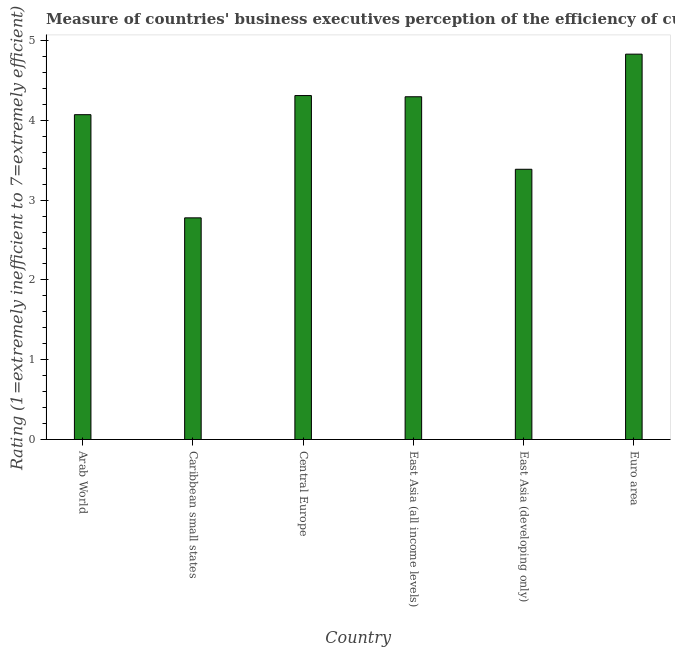Does the graph contain grids?
Offer a very short reply. No. What is the title of the graph?
Give a very brief answer. Measure of countries' business executives perception of the efficiency of customs procedures in 2007. What is the label or title of the X-axis?
Ensure brevity in your answer.  Country. What is the label or title of the Y-axis?
Offer a terse response. Rating (1=extremely inefficient to 7=extremely efficient). What is the rating measuring burden of customs procedure in Caribbean small states?
Ensure brevity in your answer.  2.78. Across all countries, what is the maximum rating measuring burden of customs procedure?
Offer a very short reply. 4.83. Across all countries, what is the minimum rating measuring burden of customs procedure?
Ensure brevity in your answer.  2.78. In which country was the rating measuring burden of customs procedure minimum?
Make the answer very short. Caribbean small states. What is the sum of the rating measuring burden of customs procedure?
Your answer should be very brief. 23.67. What is the difference between the rating measuring burden of customs procedure in Arab World and Caribbean small states?
Keep it short and to the point. 1.29. What is the average rating measuring burden of customs procedure per country?
Provide a short and direct response. 3.95. What is the median rating measuring burden of customs procedure?
Keep it short and to the point. 4.18. What is the ratio of the rating measuring burden of customs procedure in East Asia (all income levels) to that in Euro area?
Ensure brevity in your answer.  0.89. What is the difference between the highest and the second highest rating measuring burden of customs procedure?
Offer a terse response. 0.52. Is the sum of the rating measuring burden of customs procedure in Caribbean small states and East Asia (all income levels) greater than the maximum rating measuring burden of customs procedure across all countries?
Ensure brevity in your answer.  Yes. What is the difference between the highest and the lowest rating measuring burden of customs procedure?
Ensure brevity in your answer.  2.05. How many bars are there?
Offer a very short reply. 6. Are all the bars in the graph horizontal?
Make the answer very short. No. What is the Rating (1=extremely inefficient to 7=extremely efficient) of Arab World?
Provide a short and direct response. 4.07. What is the Rating (1=extremely inefficient to 7=extremely efficient) of Caribbean small states?
Offer a terse response. 2.78. What is the Rating (1=extremely inefficient to 7=extremely efficient) in Central Europe?
Your response must be concise. 4.31. What is the Rating (1=extremely inefficient to 7=extremely efficient) of East Asia (all income levels)?
Keep it short and to the point. 4.3. What is the Rating (1=extremely inefficient to 7=extremely efficient) of East Asia (developing only)?
Provide a short and direct response. 3.39. What is the Rating (1=extremely inefficient to 7=extremely efficient) in Euro area?
Your answer should be compact. 4.83. What is the difference between the Rating (1=extremely inefficient to 7=extremely efficient) in Arab World and Caribbean small states?
Offer a very short reply. 1.29. What is the difference between the Rating (1=extremely inefficient to 7=extremely efficient) in Arab World and Central Europe?
Offer a very short reply. -0.24. What is the difference between the Rating (1=extremely inefficient to 7=extremely efficient) in Arab World and East Asia (all income levels)?
Your answer should be compact. -0.22. What is the difference between the Rating (1=extremely inefficient to 7=extremely efficient) in Arab World and East Asia (developing only)?
Offer a very short reply. 0.68. What is the difference between the Rating (1=extremely inefficient to 7=extremely efficient) in Arab World and Euro area?
Your answer should be compact. -0.76. What is the difference between the Rating (1=extremely inefficient to 7=extremely efficient) in Caribbean small states and Central Europe?
Your answer should be very brief. -1.53. What is the difference between the Rating (1=extremely inefficient to 7=extremely efficient) in Caribbean small states and East Asia (all income levels)?
Give a very brief answer. -1.52. What is the difference between the Rating (1=extremely inefficient to 7=extremely efficient) in Caribbean small states and East Asia (developing only)?
Your answer should be very brief. -0.61. What is the difference between the Rating (1=extremely inefficient to 7=extremely efficient) in Caribbean small states and Euro area?
Provide a succinct answer. -2.05. What is the difference between the Rating (1=extremely inefficient to 7=extremely efficient) in Central Europe and East Asia (all income levels)?
Keep it short and to the point. 0.02. What is the difference between the Rating (1=extremely inefficient to 7=extremely efficient) in Central Europe and East Asia (developing only)?
Make the answer very short. 0.92. What is the difference between the Rating (1=extremely inefficient to 7=extremely efficient) in Central Europe and Euro area?
Offer a terse response. -0.52. What is the difference between the Rating (1=extremely inefficient to 7=extremely efficient) in East Asia (all income levels) and East Asia (developing only)?
Offer a very short reply. 0.91. What is the difference between the Rating (1=extremely inefficient to 7=extremely efficient) in East Asia (all income levels) and Euro area?
Make the answer very short. -0.53. What is the difference between the Rating (1=extremely inefficient to 7=extremely efficient) in East Asia (developing only) and Euro area?
Give a very brief answer. -1.44. What is the ratio of the Rating (1=extremely inefficient to 7=extremely efficient) in Arab World to that in Caribbean small states?
Your response must be concise. 1.47. What is the ratio of the Rating (1=extremely inefficient to 7=extremely efficient) in Arab World to that in Central Europe?
Provide a succinct answer. 0.94. What is the ratio of the Rating (1=extremely inefficient to 7=extremely efficient) in Arab World to that in East Asia (all income levels)?
Offer a terse response. 0.95. What is the ratio of the Rating (1=extremely inefficient to 7=extremely efficient) in Arab World to that in East Asia (developing only)?
Keep it short and to the point. 1.2. What is the ratio of the Rating (1=extremely inefficient to 7=extremely efficient) in Arab World to that in Euro area?
Your answer should be compact. 0.84. What is the ratio of the Rating (1=extremely inefficient to 7=extremely efficient) in Caribbean small states to that in Central Europe?
Offer a terse response. 0.64. What is the ratio of the Rating (1=extremely inefficient to 7=extremely efficient) in Caribbean small states to that in East Asia (all income levels)?
Provide a succinct answer. 0.65. What is the ratio of the Rating (1=extremely inefficient to 7=extremely efficient) in Caribbean small states to that in East Asia (developing only)?
Ensure brevity in your answer.  0.82. What is the ratio of the Rating (1=extremely inefficient to 7=extremely efficient) in Caribbean small states to that in Euro area?
Provide a succinct answer. 0.57. What is the ratio of the Rating (1=extremely inefficient to 7=extremely efficient) in Central Europe to that in East Asia (all income levels)?
Provide a succinct answer. 1. What is the ratio of the Rating (1=extremely inefficient to 7=extremely efficient) in Central Europe to that in East Asia (developing only)?
Offer a terse response. 1.27. What is the ratio of the Rating (1=extremely inefficient to 7=extremely efficient) in Central Europe to that in Euro area?
Offer a very short reply. 0.89. What is the ratio of the Rating (1=extremely inefficient to 7=extremely efficient) in East Asia (all income levels) to that in East Asia (developing only)?
Your response must be concise. 1.27. What is the ratio of the Rating (1=extremely inefficient to 7=extremely efficient) in East Asia (all income levels) to that in Euro area?
Make the answer very short. 0.89. What is the ratio of the Rating (1=extremely inefficient to 7=extremely efficient) in East Asia (developing only) to that in Euro area?
Your answer should be very brief. 0.7. 